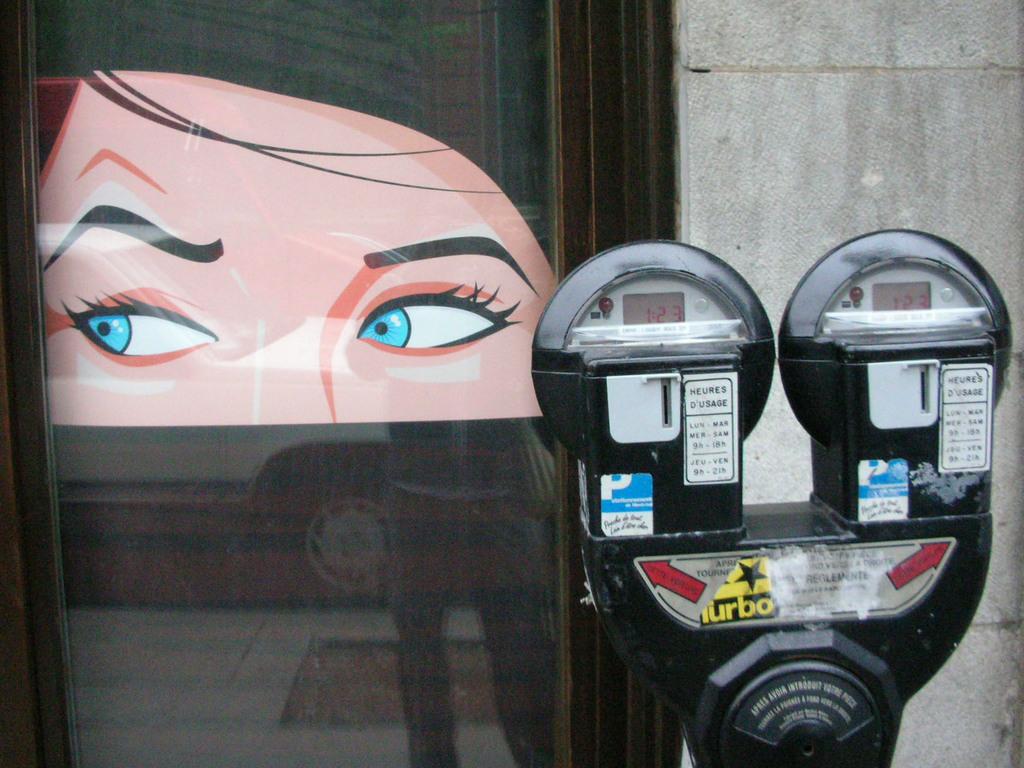What word can be seen on the toll?
Your response must be concise. Turbo. How much time left on the meter?
Provide a succinct answer. 1:23. 